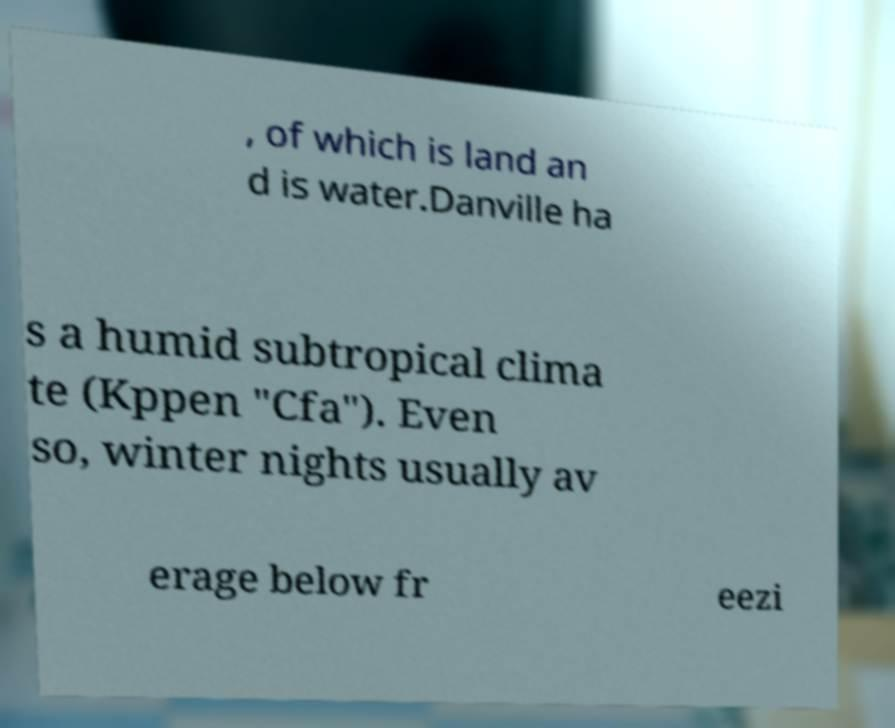Could you extract and type out the text from this image? , of which is land an d is water.Danville ha s a humid subtropical clima te (Kppen "Cfa"). Even so, winter nights usually av erage below fr eezi 